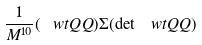Convert formula to latex. <formula><loc_0><loc_0><loc_500><loc_500>\frac { 1 } { M ^ { 1 0 } } ( \ w t Q Q ) \Sigma ( \det \ w t Q Q )</formula> 